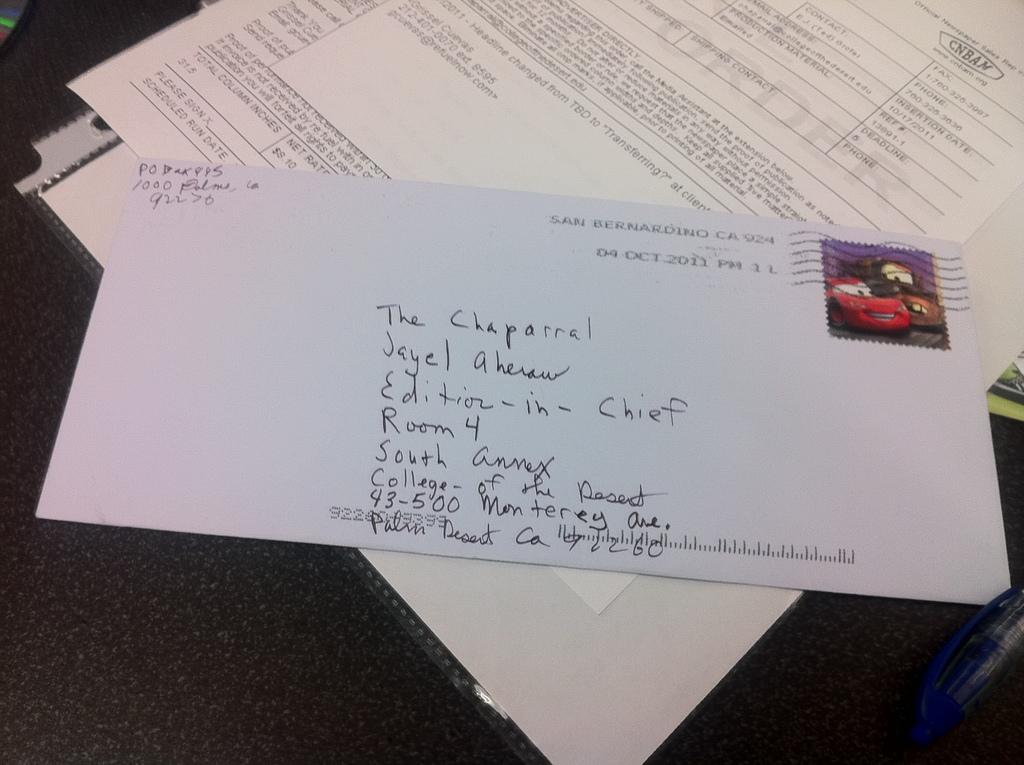<image>
Write a terse but informative summary of the picture. An envelope is addressed to the editor of the Chaparral. 